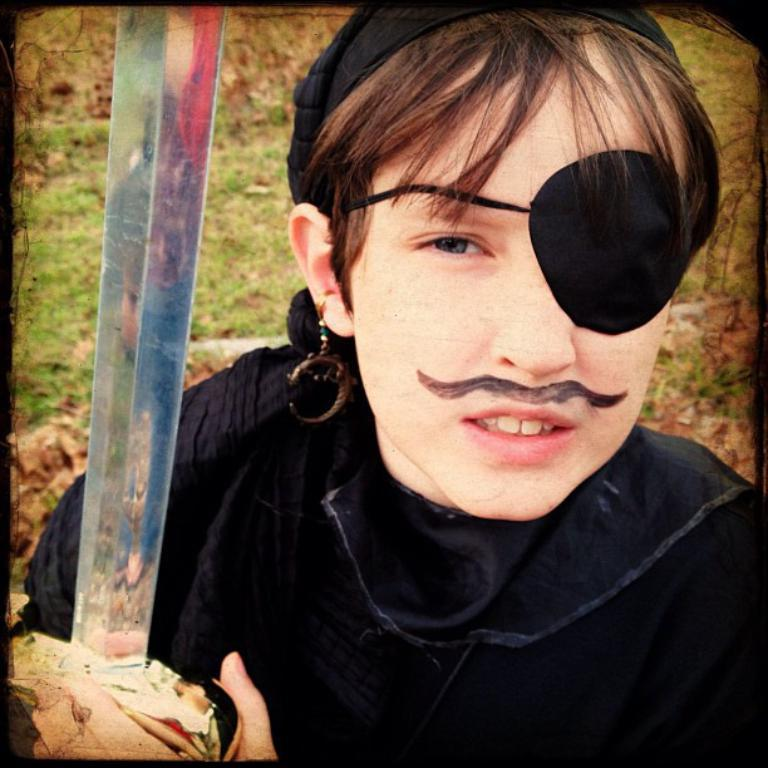Who or what is present in the image? There is a person in the image. What is the person wearing? The person is wearing a black dress. What is the person holding in the image? The person is holding a knife. What can be seen in the background of the image? There is green grass visible in the background of the image. How many flies can be seen on the person's shoulder in the image? There are no flies visible on the person's shoulder in the image. What scientific discovery was made by the person in the image? The image does not provide any information about a scientific discovery made by the person. 